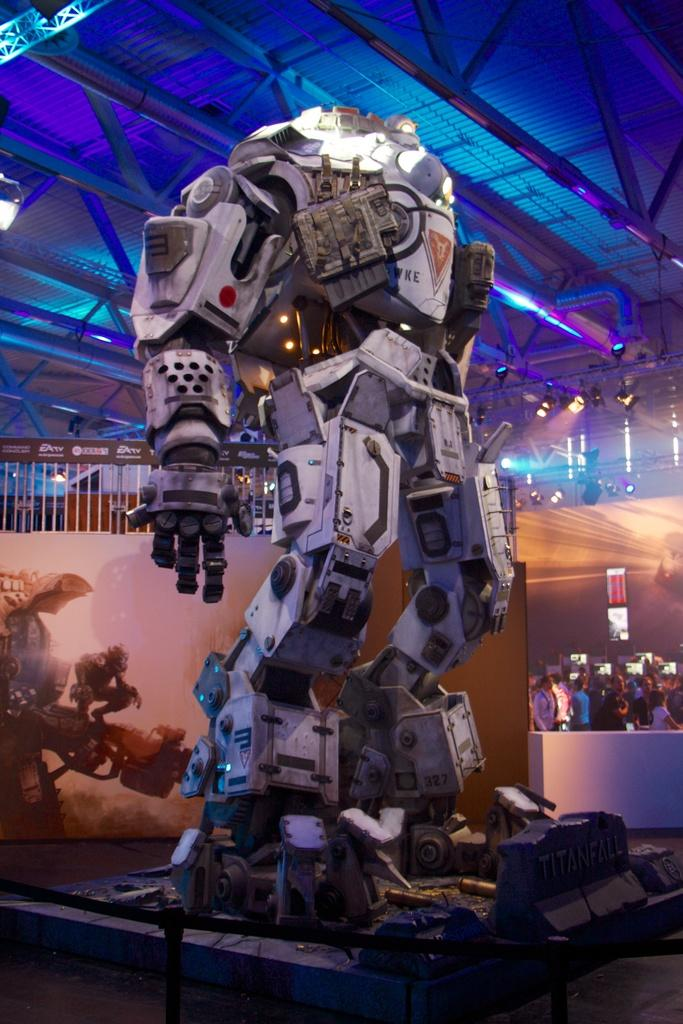What is the main subject of the image? The main subject of the image is a robot. What is the purpose of the robot in the image? The robot is for an expo. Can you describe the surroundings of the robot? There is a crowd behind the robot. What color light is fitted to the roof in the image? There is a blue color light fitted to the roof. What type of zipper can be seen on the robot's arm in the image? There is no zipper present on the robot's arm in the image. How many members are in the team that created the robot? The image does not provide information about the team that created the robot, so we cannot determine the number of members. 